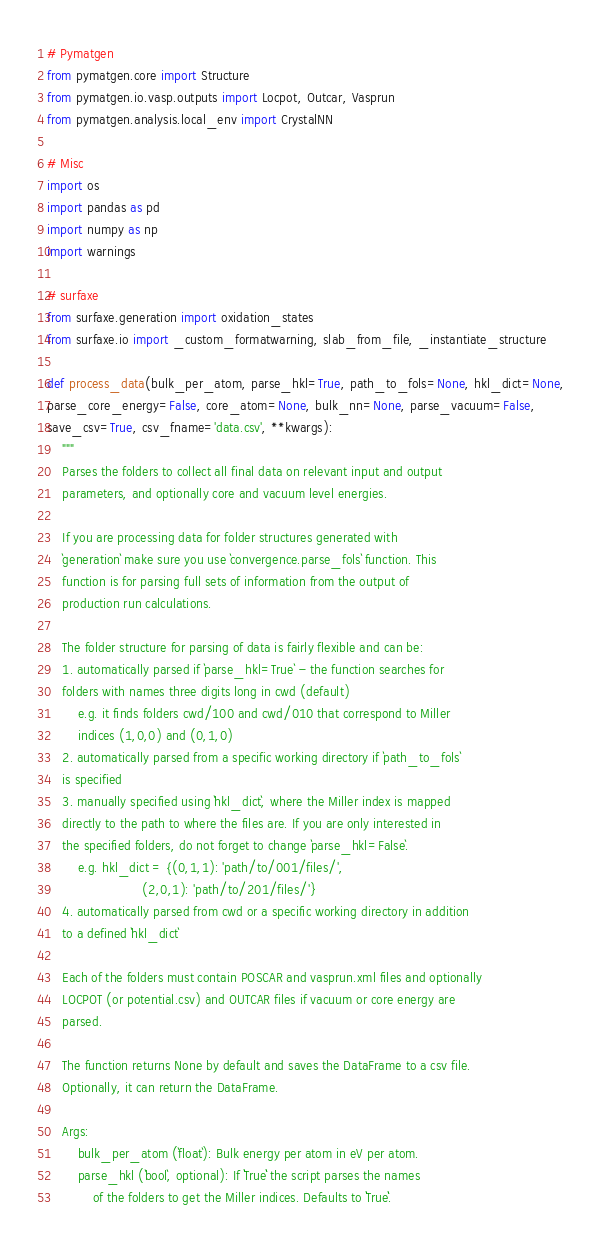Convert code to text. <code><loc_0><loc_0><loc_500><loc_500><_Python_># Pymatgen  
from pymatgen.core import Structure
from pymatgen.io.vasp.outputs import Locpot, Outcar, Vasprun
from pymatgen.analysis.local_env import CrystalNN

# Misc
import os
import pandas as pd 
import numpy as np 
import warnings 

# surfaxe 
from surfaxe.generation import oxidation_states
from surfaxe.io import _custom_formatwarning, slab_from_file, _instantiate_structure

def process_data(bulk_per_atom, parse_hkl=True, path_to_fols=None, hkl_dict=None,
parse_core_energy=False, core_atom=None, bulk_nn=None, parse_vacuum=False, 
save_csv=True, csv_fname='data.csv', **kwargs): 
    """
    Parses the folders to collect all final data on relevant input and output 
    parameters, and optionally core and vacuum level energies. 

    If you are processing data for folder structures generated with 
    `generation` make sure you use `convergence.parse_fols` function. This 
    function is for parsing full sets of information from the output of 
    production run calculations. 

    The folder structure for parsing of data is fairly flexible and can be: 
    1. automatically parsed if `parse_hkl=True` - the function searches for 
    folders with names three digits long in cwd (default)
        e.g. it finds folders cwd/100 and cwd/010 that correspond to Miller 
        indices (1,0,0) and (0,1,0)
    2. automatically parsed from a specific working directory if `path_to_fols`
    is specified
    3. manually specified using `hkl_dict`, where the Miller index is mapped 
    directly to the path to where the files are. If you are only interested in 
    the specified folders, do not forget to change `parse_hkl=False`.
        e.g. hkl_dict = {(0,1,1): 'path/to/001/files/', 
                         (2,0,1): 'path/to/201/files/'}
    4. automatically parsed from cwd or a specific working directory in addition 
    to a defined `hkl_dict`

    Each of the folders must contain POSCAR and vasprun.xml files and optionally 
    LOCPOT (or potential.csv) and OUTCAR files if vacuum or core energy are 
    parsed. 

    The function returns None by default and saves the DataFrame to a csv file. 
    Optionally, it can return the DataFrame. 

    Args:
        bulk_per_atom (`float`): Bulk energy per atom in eV per atom. 
        parse_hkl (`bool`, optional): If ``True`` the script parses the names   
            of the folders to get the Miller indices. Defaults to ``True``.</code> 